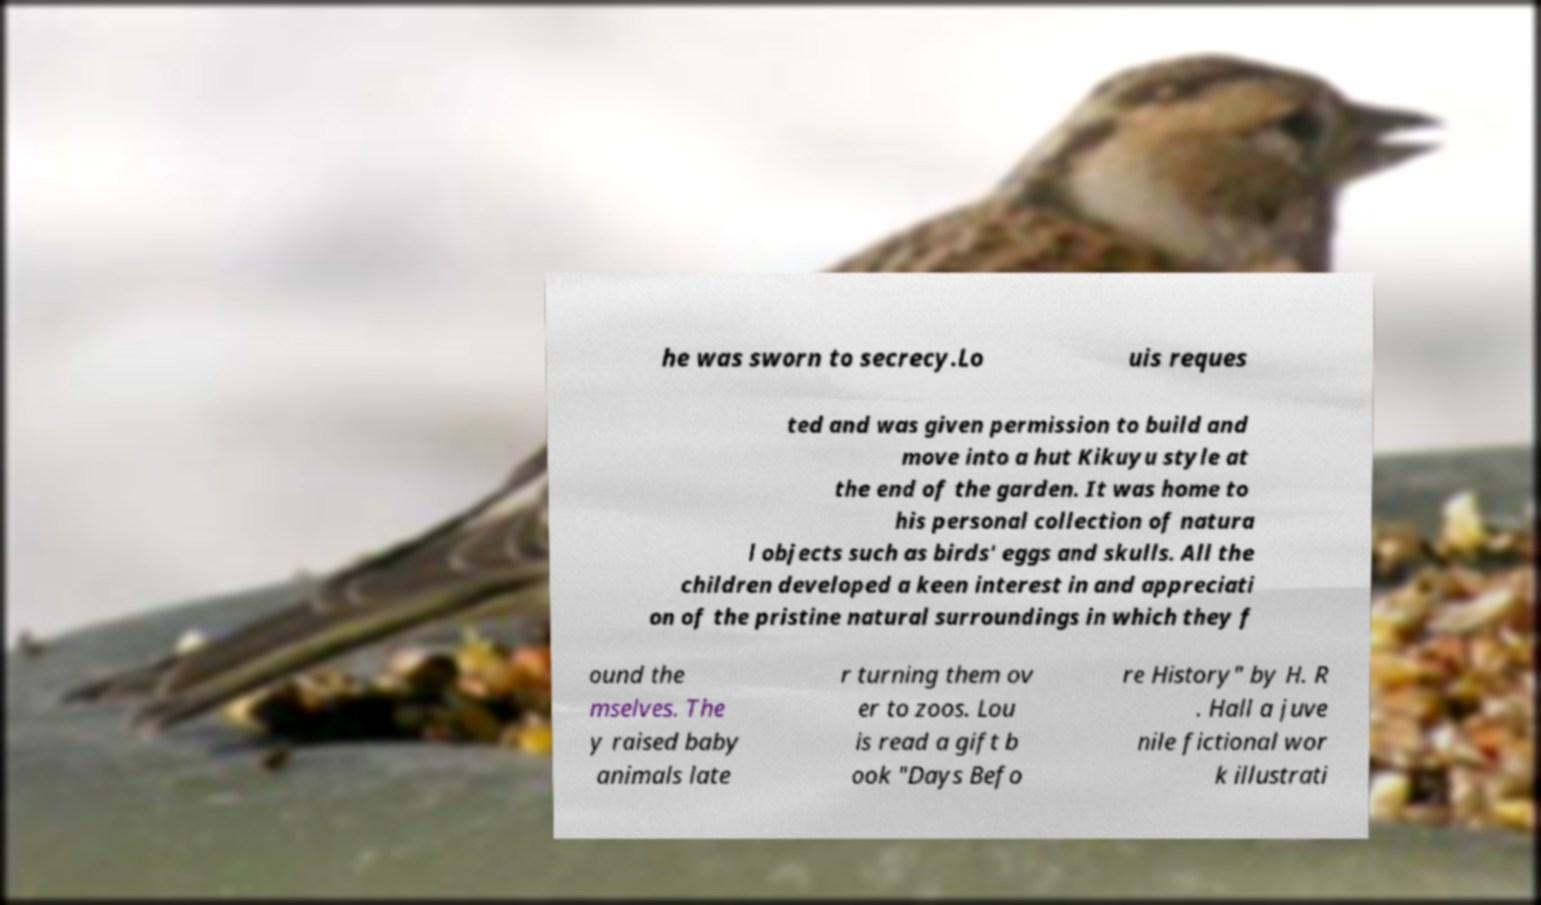I need the written content from this picture converted into text. Can you do that? he was sworn to secrecy.Lo uis reques ted and was given permission to build and move into a hut Kikuyu style at the end of the garden. It was home to his personal collection of natura l objects such as birds' eggs and skulls. All the children developed a keen interest in and appreciati on of the pristine natural surroundings in which they f ound the mselves. The y raised baby animals late r turning them ov er to zoos. Lou is read a gift b ook "Days Befo re History" by H. R . Hall a juve nile fictional wor k illustrati 